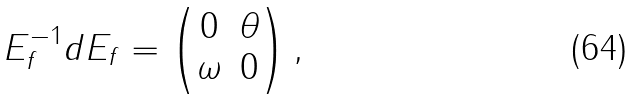<formula> <loc_0><loc_0><loc_500><loc_500>E _ { f } ^ { - 1 } d E _ { f } = \begin{pmatrix} 0 & \theta \\ \omega & 0 \end{pmatrix} ,</formula> 